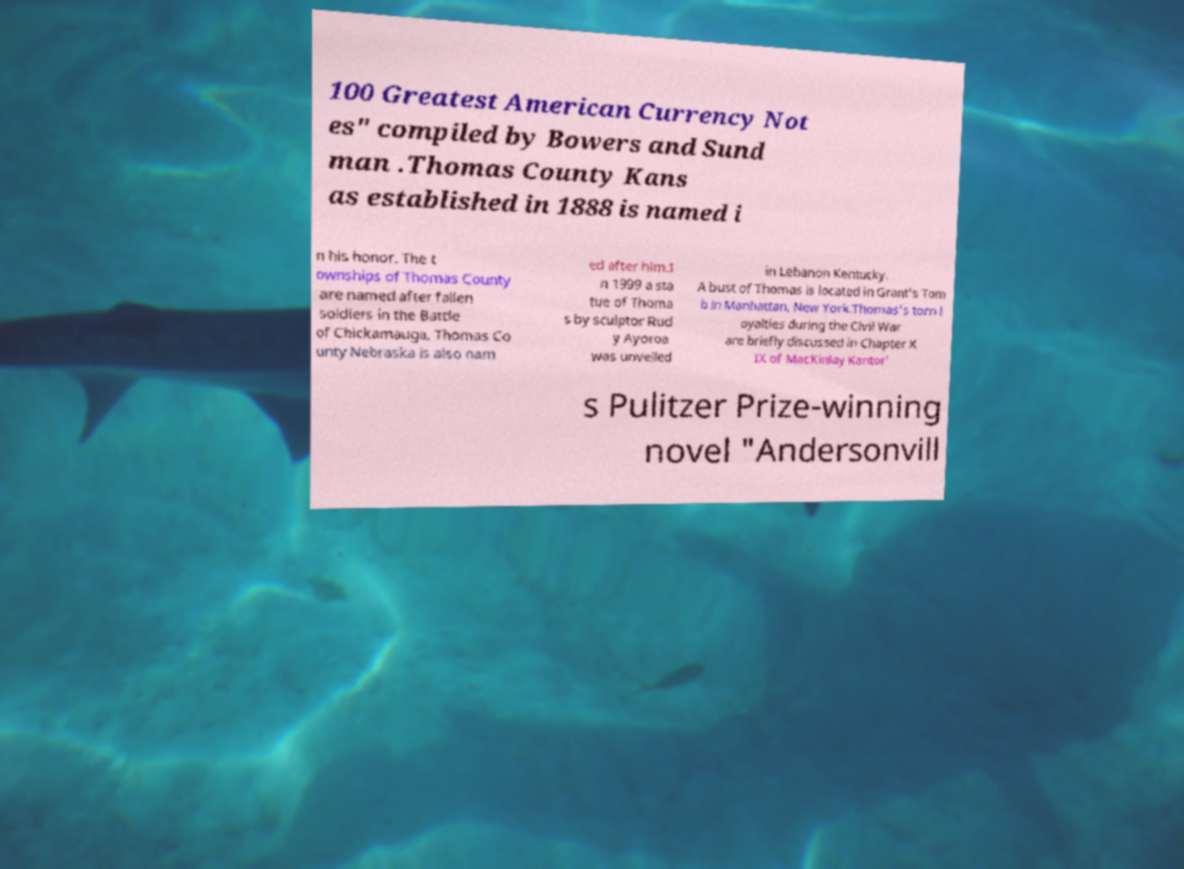Can you read and provide the text displayed in the image?This photo seems to have some interesting text. Can you extract and type it out for me? 100 Greatest American Currency Not es" compiled by Bowers and Sund man .Thomas County Kans as established in 1888 is named i n his honor. The t ownships of Thomas County are named after fallen soldiers in the Battle of Chickamauga. Thomas Co unty Nebraska is also nam ed after him.I n 1999 a sta tue of Thoma s by sculptor Rud y Ayoroa was unveiled in Lebanon Kentucky. A bust of Thomas is located in Grant's Tom b in Manhattan, New York.Thomas's torn l oyalties during the Civil War are briefly discussed in Chapter X IX of MacKinlay Kantor' s Pulitzer Prize-winning novel "Andersonvill 